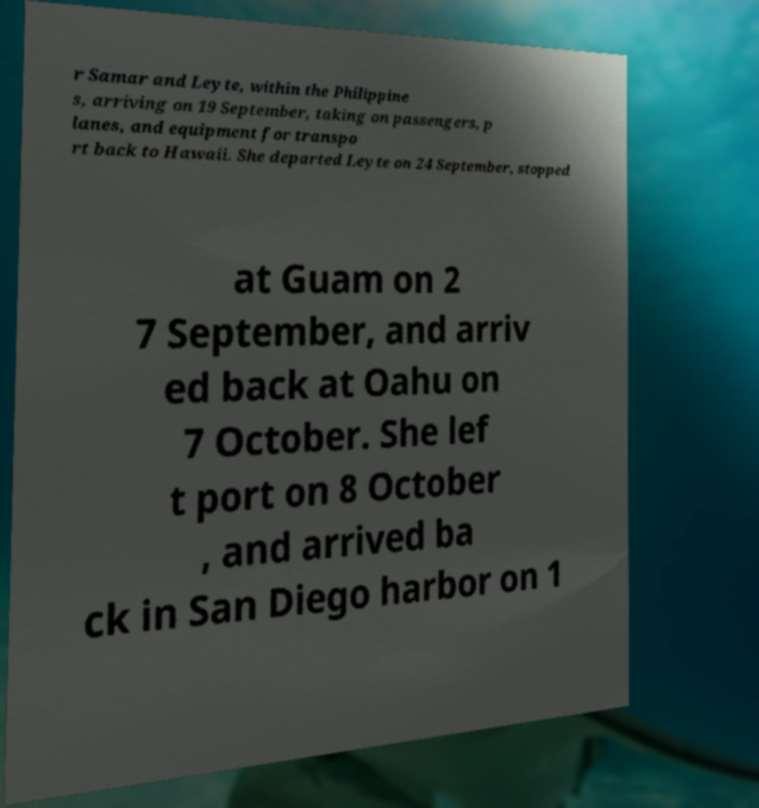Could you assist in decoding the text presented in this image and type it out clearly? r Samar and Leyte, within the Philippine s, arriving on 19 September, taking on passengers, p lanes, and equipment for transpo rt back to Hawaii. She departed Leyte on 24 September, stopped at Guam on 2 7 September, and arriv ed back at Oahu on 7 October. She lef t port on 8 October , and arrived ba ck in San Diego harbor on 1 